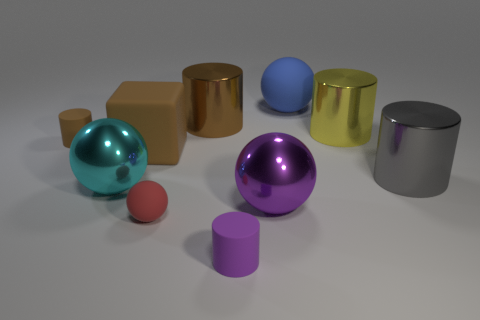Is the material of the big brown cylinder the same as the tiny purple thing?
Your response must be concise. No. Are there any metal spheres left of the sphere that is to the left of the brown thing in front of the small brown object?
Ensure brevity in your answer.  No. What is the color of the large rubber ball?
Your answer should be very brief. Blue. The cube that is the same size as the cyan shiny object is what color?
Offer a very short reply. Brown. Does the shiny thing that is in front of the large cyan shiny object have the same shape as the purple rubber object?
Ensure brevity in your answer.  No. There is a cylinder that is in front of the metal cylinder that is in front of the large yellow metallic cylinder on the right side of the small red rubber sphere; what color is it?
Your response must be concise. Purple. Is there a big purple cylinder?
Keep it short and to the point. No. How many other objects are there of the same size as the yellow object?
Offer a terse response. 6. Is the color of the small sphere the same as the small rubber object behind the brown block?
Your answer should be very brief. No. What number of objects are either big matte blocks or small cyan shiny blocks?
Ensure brevity in your answer.  1. 